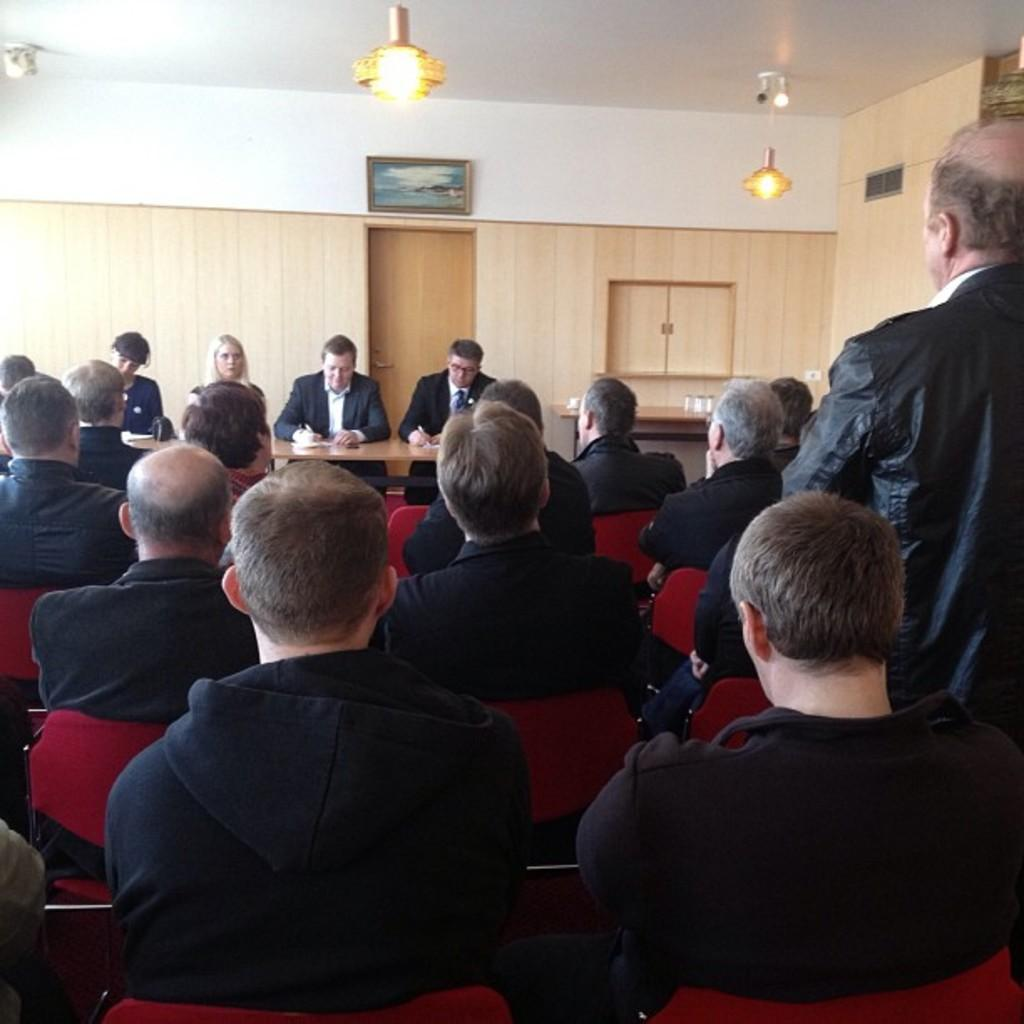What color are the chairs that the people are sitting on? The people are sitting on red chairs. What color are the clothes that the people are wearing? The people are wearing black dresses. What is the position of the man in the image? A man is standing at the right side. What type of furniture is present in the image? There is a table in the image. What architectural feature is visible in the image? There is a door in the image. What type of decorative item is present in the image? There is a photo frame in the image. What is visible at the top of the image? Lights are visible at the top of the image. How many children are playing with the cannon in the image? There are no children or cannon present in the image. What is the reason for the people falling in the image? There is no indication of anyone falling in the image. 